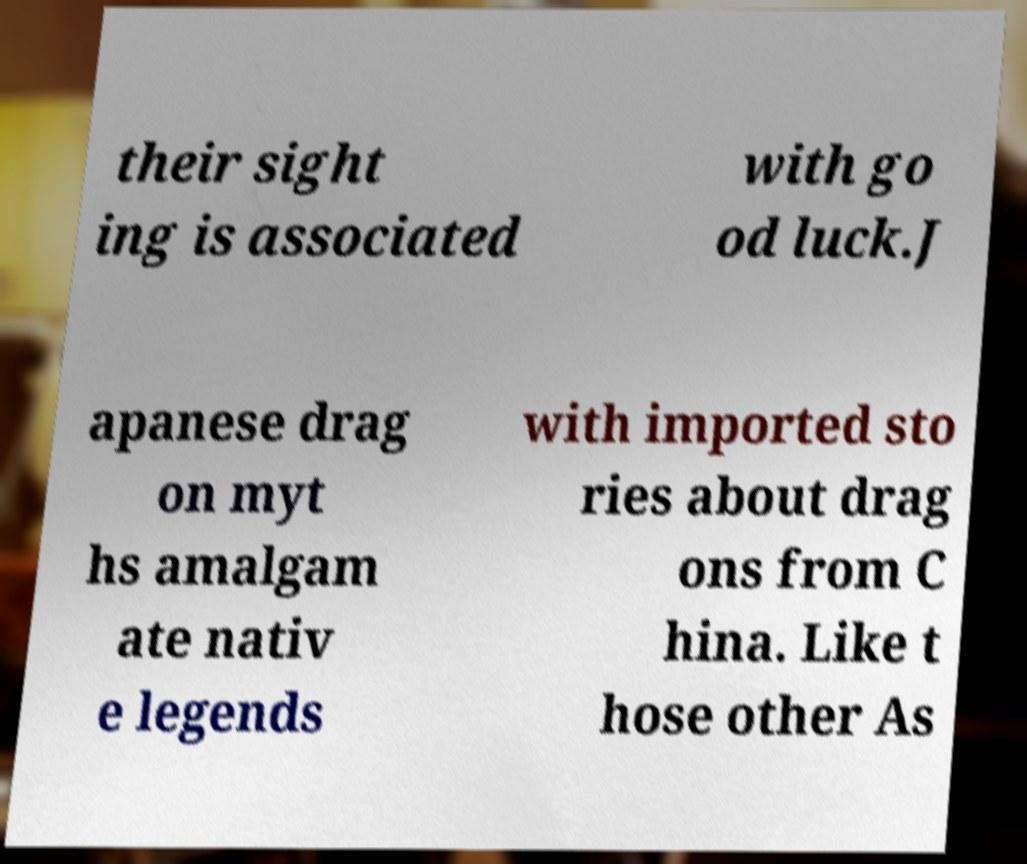Please read and relay the text visible in this image. What does it say? their sight ing is associated with go od luck.J apanese drag on myt hs amalgam ate nativ e legends with imported sto ries about drag ons from C hina. Like t hose other As 